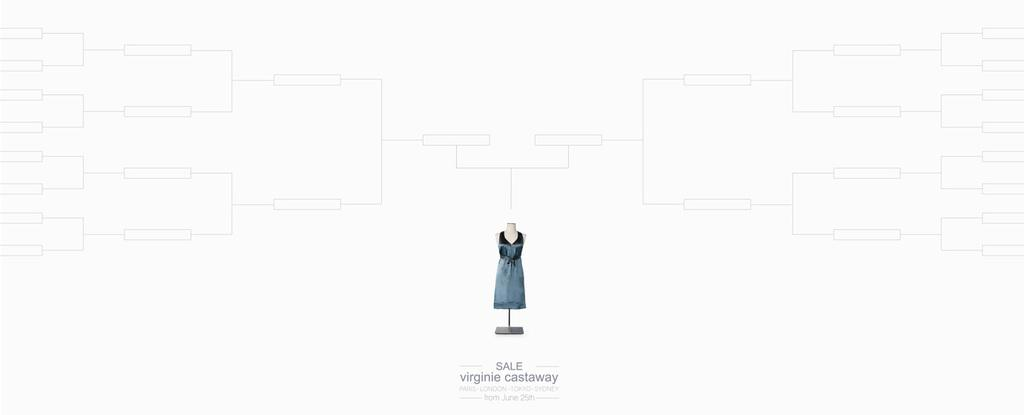What is displayed on the mannequin in the image? There is a dress on a mannequin in the image. What type of text can be seen at the bottom of the image? The text at the bottom of the image is edited. How would you describe the color scheme of the lines in the image? The lines in the image have a black color on a white color background. Are there any plastic materials visible in the image? There is no mention of plastic materials in the provided facts, so we cannot determine if any are present in the image. 